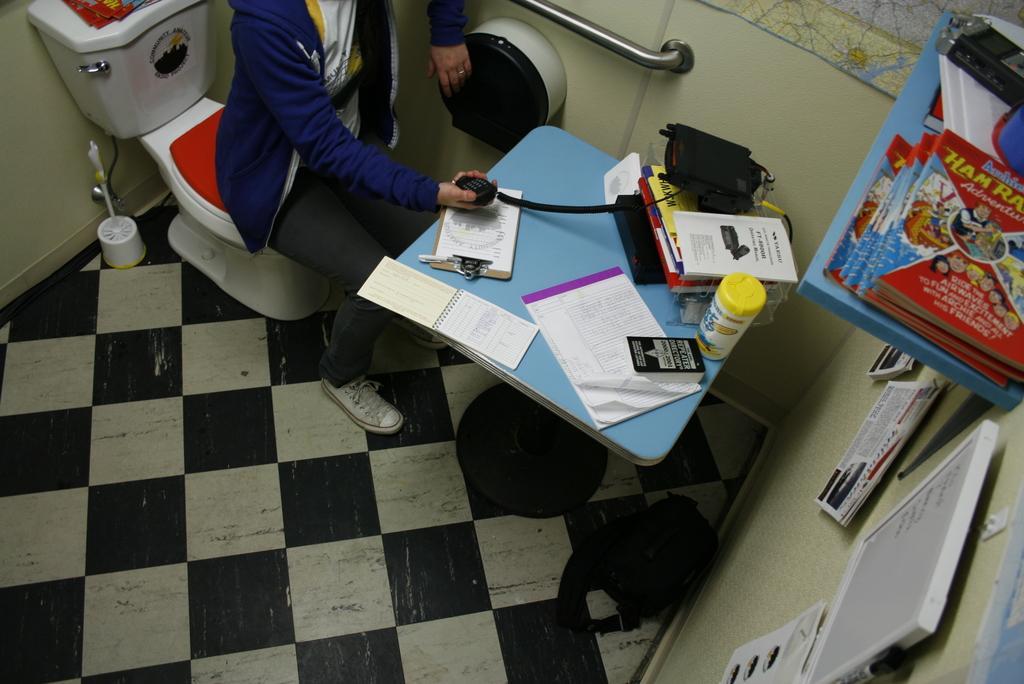How would you summarize this image in a sentence or two? In this image I see a person who is sitting on the toilet seat and the person is in front of a table on which there are books, an electronic device in the person's hand and other things. I can also see the wall on which there are few things and I see a bag over here. 